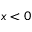<formula> <loc_0><loc_0><loc_500><loc_500>x < 0</formula> 